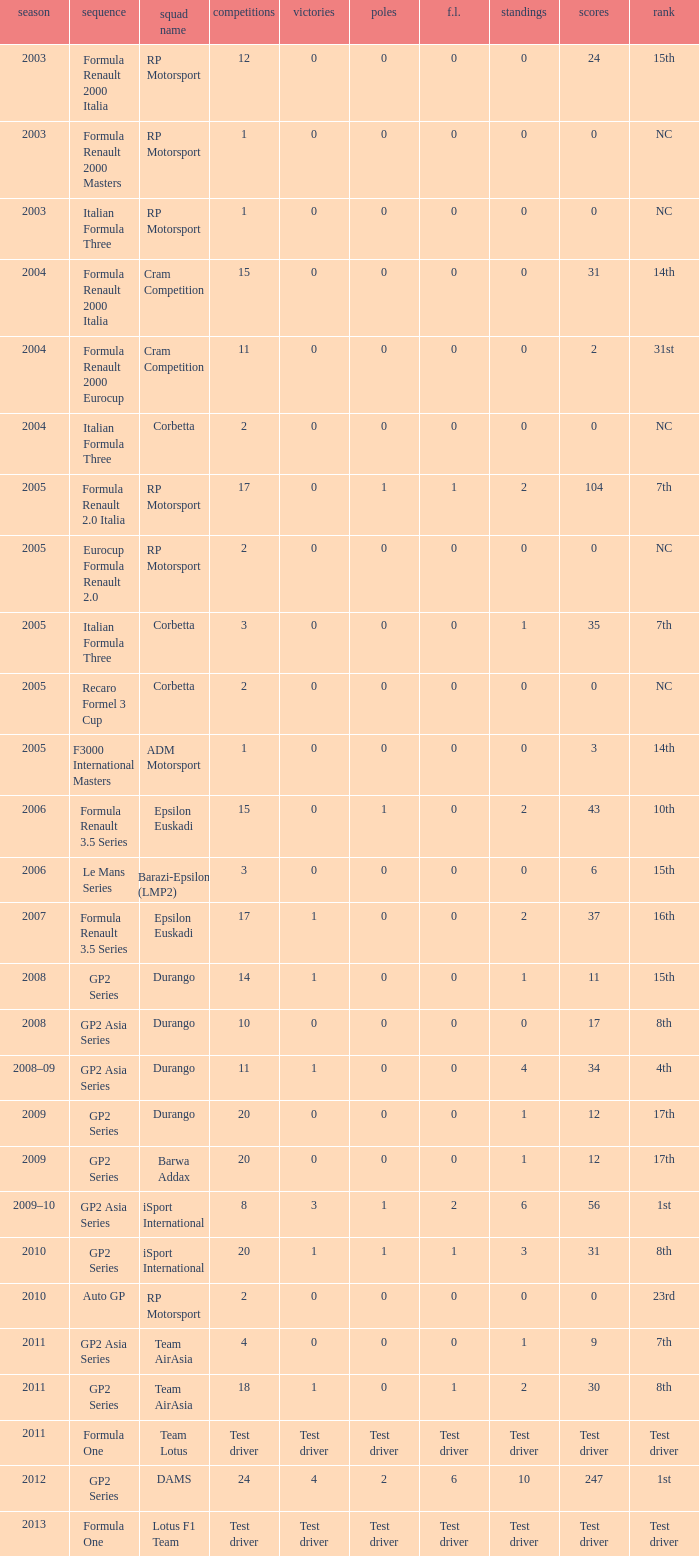What is the number of podiums with 0 wins, 0 F.L. and 35 points? 1.0. 